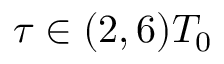<formula> <loc_0><loc_0><loc_500><loc_500>\tau \in ( 2 , 6 ) T _ { 0 }</formula> 